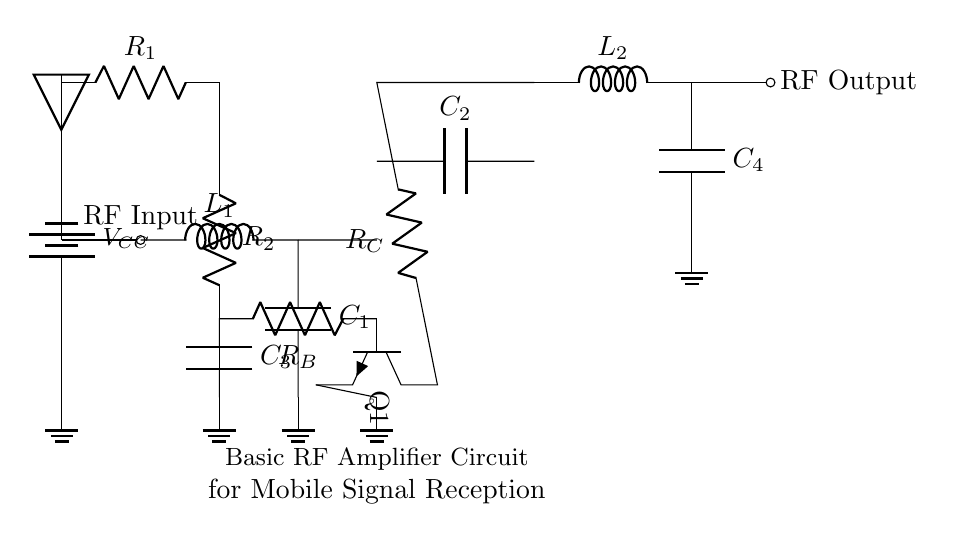What type of transistor is used in this circuit? The circuit diagram shows an npn transistor labeled Q1, which is used for amplifying RF signals.
Answer: npn What is the purpose of the inductor L1? Inductor L1 is part of the matching network, which helps to match the impedance of the antenna to the amplifier, optimizing signal transfer.
Answer: Matching What is the DC voltage supply for this circuit? The circuit includes a battery labeled VCC that provides the DC voltage necessary for the operation of the RF amplifier, which is typically a nominal voltage like 5V or 12V.
Answer: VCC How many capacitors are present in the circuit? The circuit shows three capacitors, C1, C2, and C3, used for different purposes including filtering and ensuring stable operation of the amplifier.
Answer: Three What component provides the biasing for the transistor? The biasing for the transistor is provided by resistors R1 and R2, which set the operating point of the transistor to ensure proper amplification.
Answer: Resistors What is the output connection of the circuit? The output connection is indicated as RF Output, which is the point where the amplified RF signal is transmitted after processing.
Answer: RF Output How does the capacitor C4 contribute to the circuit? C4 is part of the output matching network, helping to filter out unwanted frequencies and optimize the signal before it is transmitted.
Answer: Filtering 